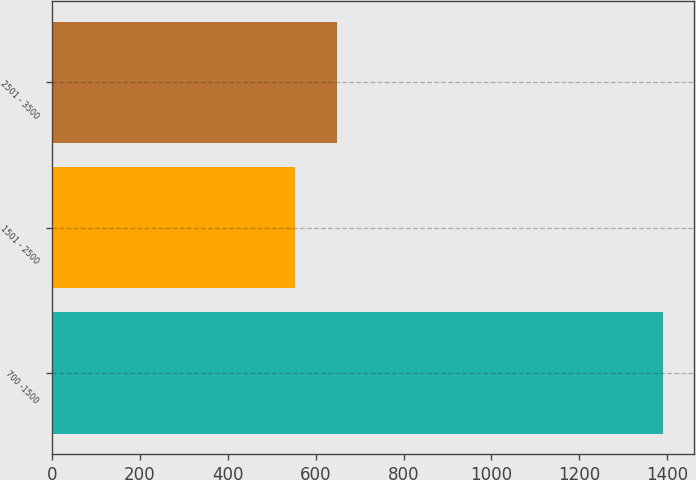Convert chart. <chart><loc_0><loc_0><loc_500><loc_500><bar_chart><fcel>700 -1500<fcel>1501 - 2500<fcel>2501 - 3500<nl><fcel>1390<fcel>553<fcel>648<nl></chart> 